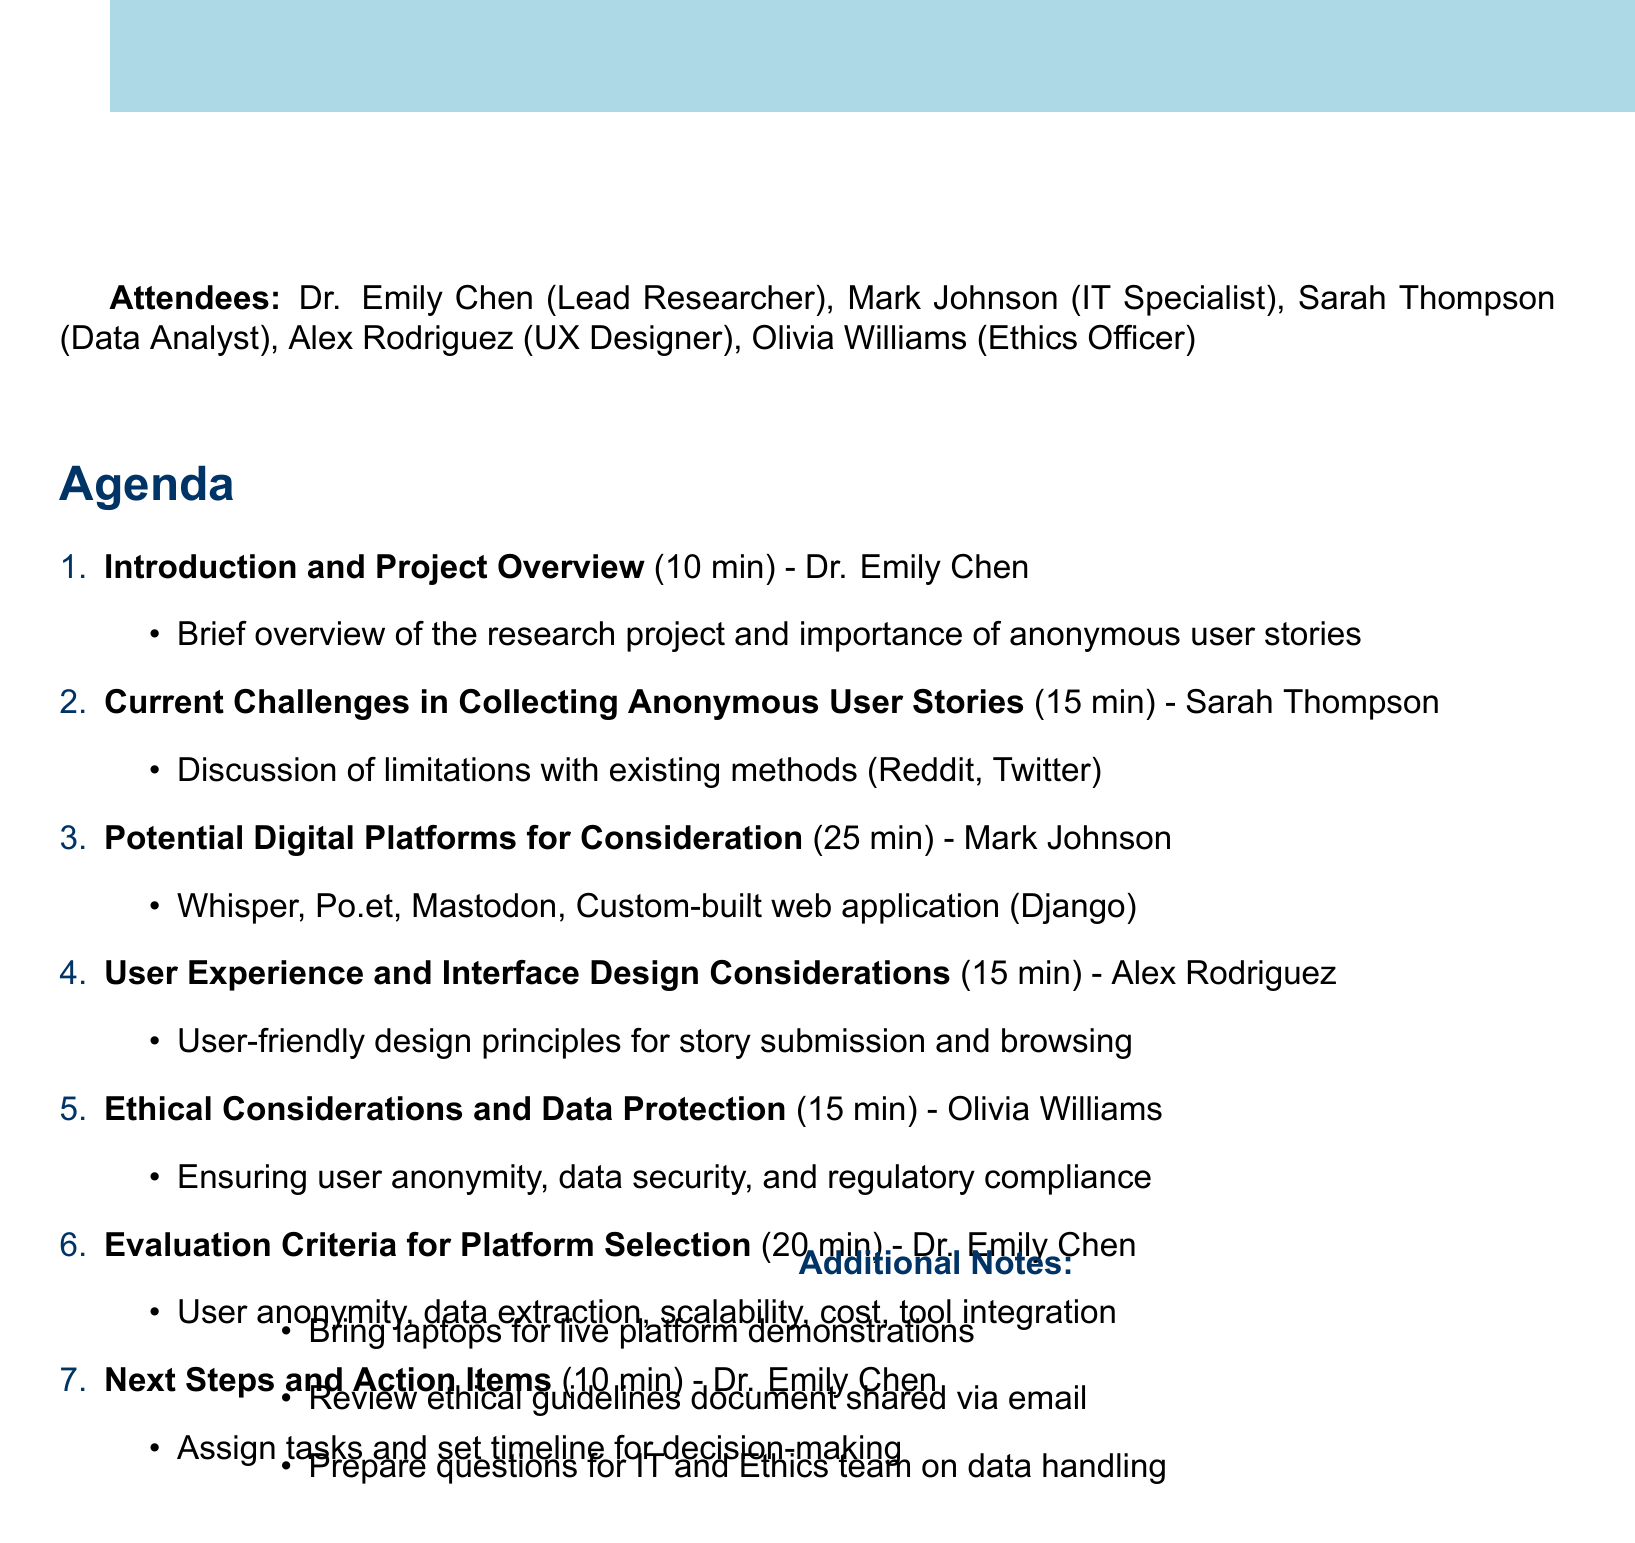What is the meeting date? The meeting date is explicitly stated in the document as May 15, 2023.
Answer: May 15, 2023 Who is the presenter for the "Ethical Considerations and Data Protection" agenda item? The document lists Olivia Williams as the presenter for the mentioned agenda item.
Answer: Olivia Williams How long is the "Potential Digital Platforms for Consideration" discussion? The document specifies that this agenda item is allocated 25 minutes for discussion.
Answer: 25 minutes What is the location of the meeting? The meeting location is clearly indicated in the document as Conference Room A.
Answer: Conference Room A What is the main focus of the "Evaluation Criteria for Platform Selection" agenda item? The document details the focus areas for evaluation criteria, specifically user anonymity and security, among others.
Answer: User anonymity and security What additional materials should attendees bring? The document mentions bringing laptops for live platform demonstrations.
Answer: Laptops How many attendees are listed in the document? The document lists five attendees for the meeting.
Answer: Five What is one ethical concern mentioned in the meeting agenda? The agenda highlights the importance of ensuring user anonymity as an ethical concern.
Answer: User anonymity 